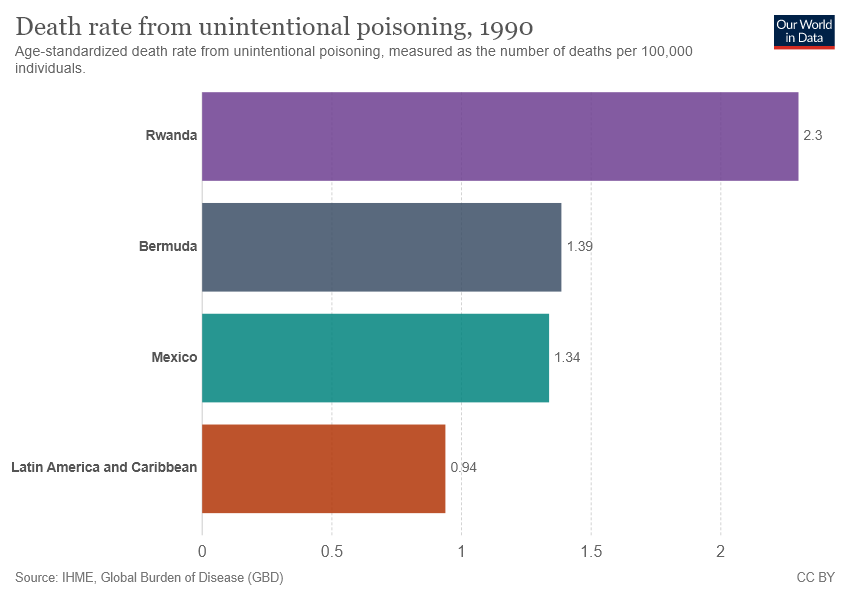Give some essential details in this illustration. The name of the first bar is Rwanda. The sum of the smallest two bars is not equal to the value of the largest bar. 